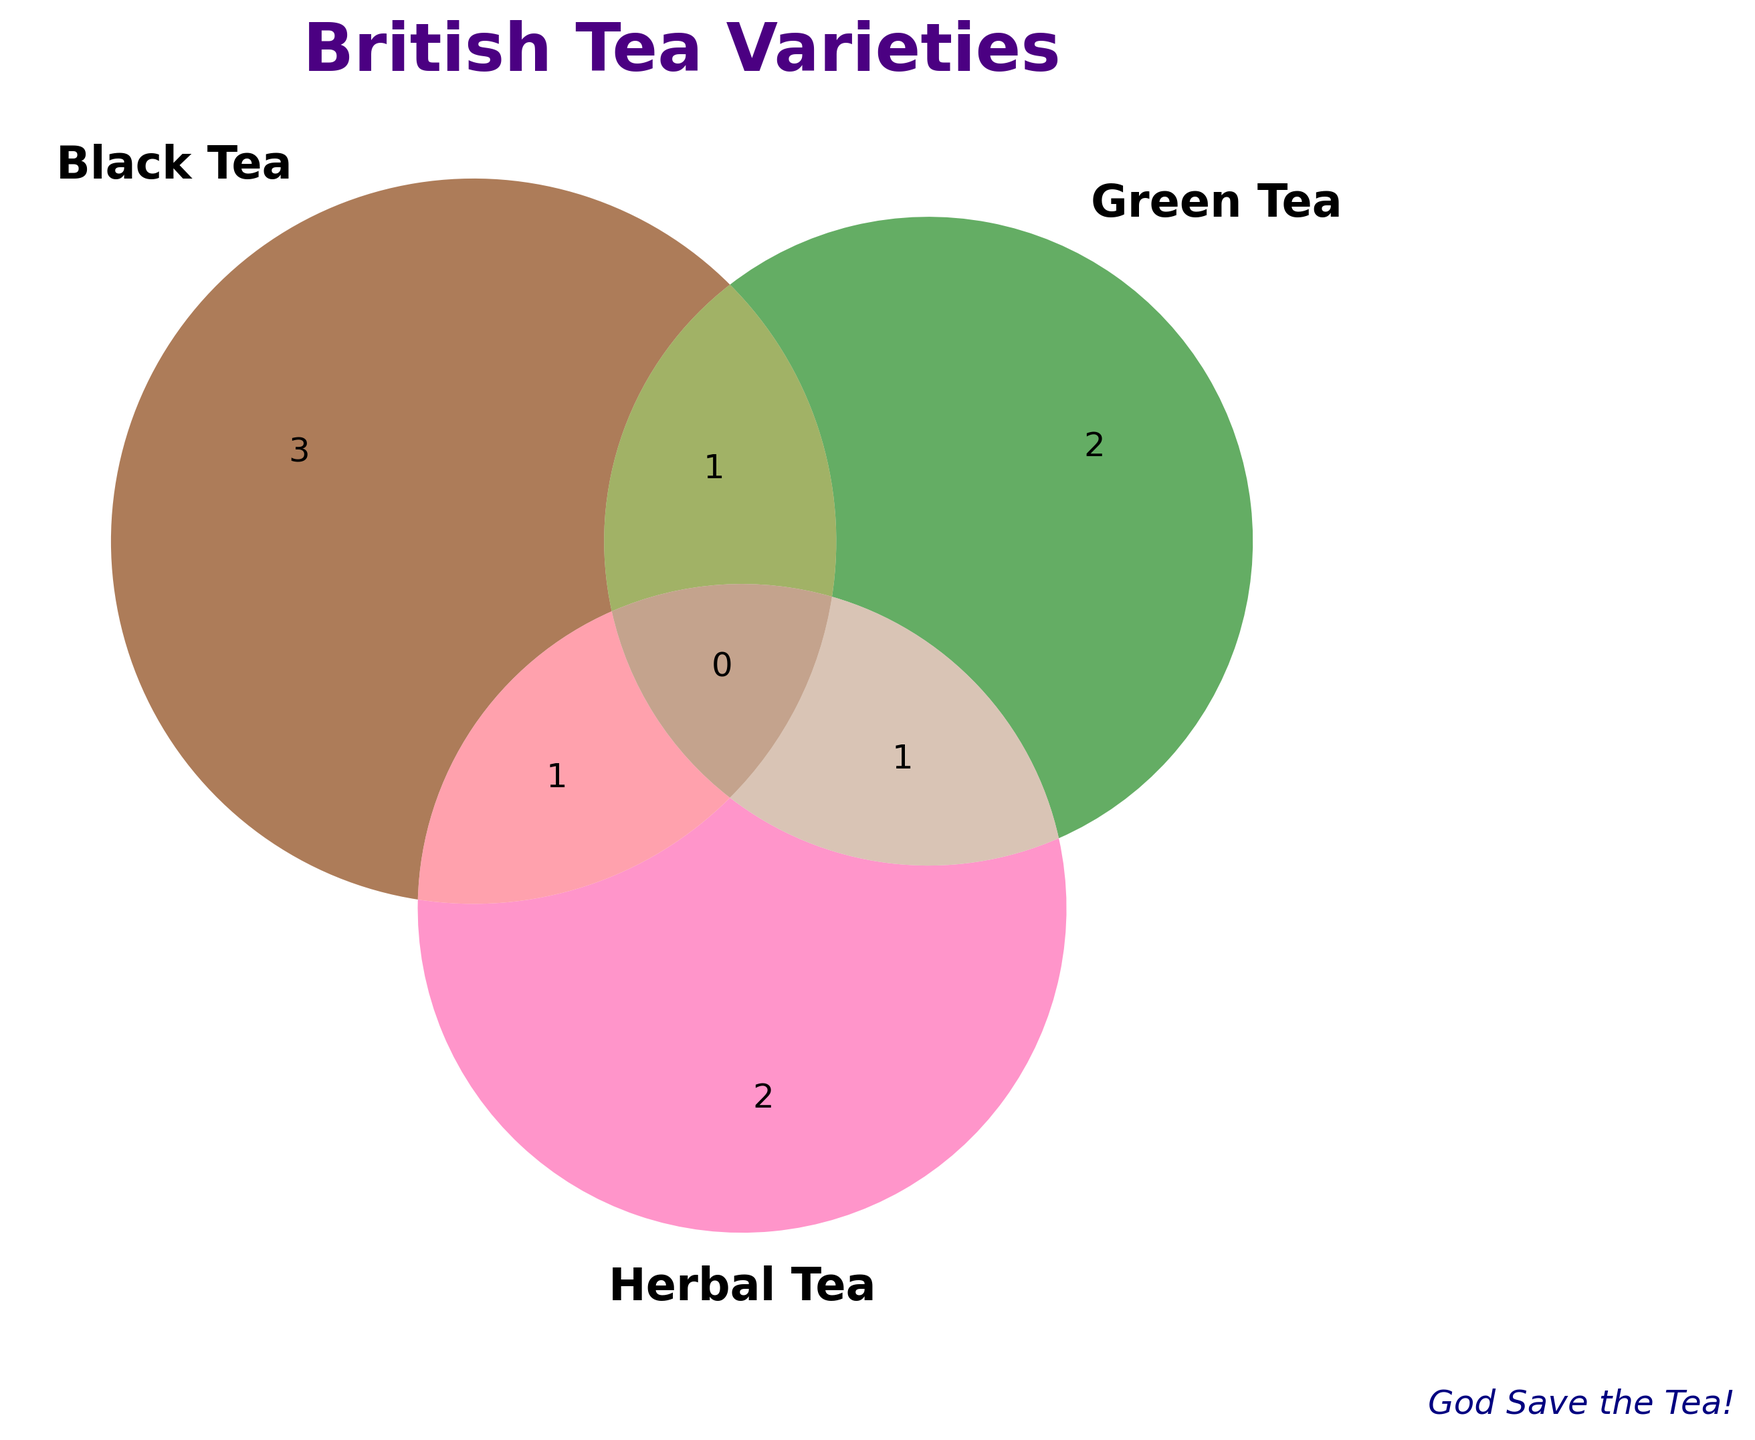What are the three categories of tea shown in the diagram? The Venn diagram labels indicate three categories: Black Tea, Green Tea, and Herbal Tea, each with its own color.
Answer: Black Tea, Green Tea, Herbal Tea Which category does 'Earl Grey' belong to? 'Earl Grey' is located in the Black Tea circle.
Answer: Black Tea How many tea varieties are exclusive to Green Tea? Only 'Gunpowder' and 'Sencha' are within the Green Tea circle, not overlapping with others.
Answer: 2 Which tea variety is categorized under both Black Tea and Herbal Tea? 'Chai' is located in the overlap area between Black Tea and Herbal Tea.
Answer: Chai Identify a tea variety that falls under both Green Tea and Herbal Tea. 'Jasmine' appears in the intersection between Green Tea and Herbal Tea.
Answer: Jasmine How many tea varieties belong exclusively to Black Tea? 'English Breakfast,' 'Earl Grey,' and 'Darjeeling' are in the Black Tea circle without any overlap.
Answer: 3 Which tea variety is shared between Black Tea and Green Tea? 'Oolong' is found in the intersection of the Black Tea and Green Tea circles.
Answer: Oolong Compare the number of tea varieties exclusive to Black Tea versus those exclusive to Herbal Tea. Black Tea has three exclusive varieties ('English Breakfast,' 'Earl Grey,' 'Darjeeling') while Herbal Tea has two ('Peppermint,' 'Chamomile').
Answer: Black Tea has more What is the total number of unique tea varieties shown? Counting each unique tea variety from all sections of the Venn diagram: 'English Breakfast,' 'Earl Grey,' 'Darjeeling,' 'Gunpowder,' 'Sencha,' 'Peppermint,' 'Chamomile,' 'Oolong,' 'Chai,' and 'Jasmine' sums up to 10.
Answer: 10 What's the title of the diagram? The title is displayed at the top center of the Venn diagram and reads "British Tea Varieties."
Answer: British Tea Varieties 